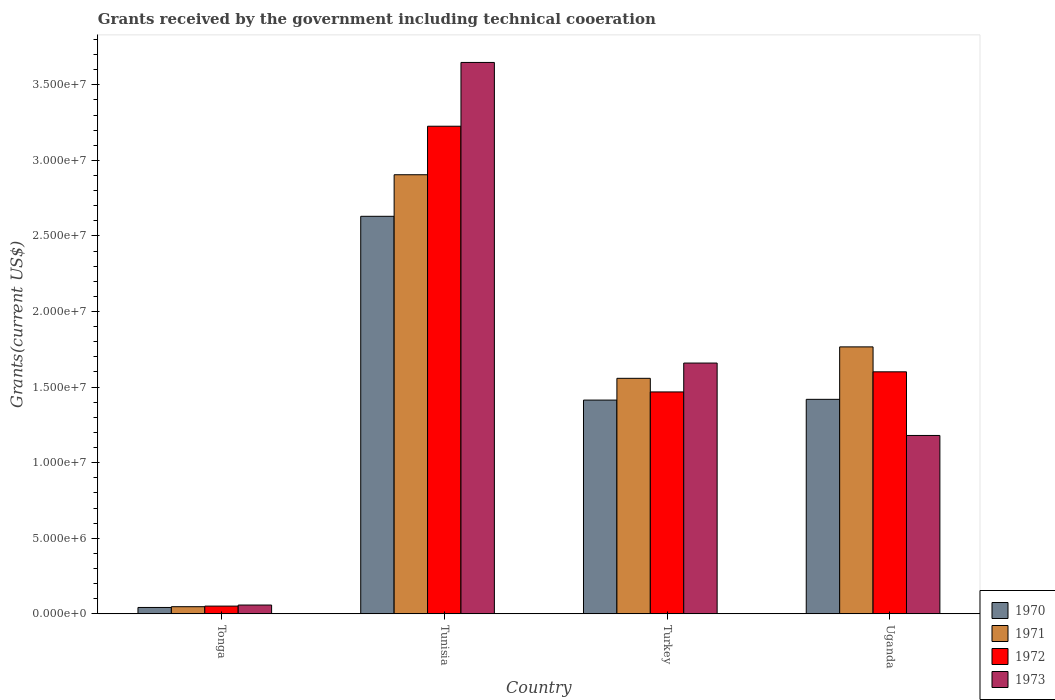How many groups of bars are there?
Offer a very short reply. 4. Are the number of bars on each tick of the X-axis equal?
Your answer should be compact. Yes. How many bars are there on the 2nd tick from the left?
Offer a very short reply. 4. What is the label of the 2nd group of bars from the left?
Offer a very short reply. Tunisia. In how many cases, is the number of bars for a given country not equal to the number of legend labels?
Your response must be concise. 0. What is the total grants received by the government in 1973 in Uganda?
Your answer should be compact. 1.18e+07. Across all countries, what is the maximum total grants received by the government in 1973?
Make the answer very short. 3.65e+07. Across all countries, what is the minimum total grants received by the government in 1971?
Provide a succinct answer. 4.70e+05. In which country was the total grants received by the government in 1972 maximum?
Give a very brief answer. Tunisia. In which country was the total grants received by the government in 1970 minimum?
Your response must be concise. Tonga. What is the total total grants received by the government in 1970 in the graph?
Make the answer very short. 5.50e+07. What is the difference between the total grants received by the government in 1973 in Tonga and that in Tunisia?
Your answer should be compact. -3.59e+07. What is the difference between the total grants received by the government in 1972 in Turkey and the total grants received by the government in 1973 in Uganda?
Ensure brevity in your answer.  2.88e+06. What is the average total grants received by the government in 1970 per country?
Ensure brevity in your answer.  1.38e+07. What is the difference between the total grants received by the government of/in 1971 and total grants received by the government of/in 1970 in Turkey?
Your answer should be compact. 1.44e+06. In how many countries, is the total grants received by the government in 1972 greater than 32000000 US$?
Offer a terse response. 1. What is the ratio of the total grants received by the government in 1970 in Tonga to that in Uganda?
Your answer should be compact. 0.03. Is the difference between the total grants received by the government in 1971 in Tunisia and Turkey greater than the difference between the total grants received by the government in 1970 in Tunisia and Turkey?
Your response must be concise. Yes. What is the difference between the highest and the second highest total grants received by the government in 1973?
Provide a succinct answer. 1.99e+07. What is the difference between the highest and the lowest total grants received by the government in 1973?
Provide a short and direct response. 3.59e+07. In how many countries, is the total grants received by the government in 1970 greater than the average total grants received by the government in 1970 taken over all countries?
Keep it short and to the point. 3. Is the sum of the total grants received by the government in 1970 in Tonga and Tunisia greater than the maximum total grants received by the government in 1973 across all countries?
Offer a terse response. No. Is it the case that in every country, the sum of the total grants received by the government in 1973 and total grants received by the government in 1972 is greater than the sum of total grants received by the government in 1970 and total grants received by the government in 1971?
Provide a succinct answer. No. What does the 2nd bar from the left in Tonga represents?
Your answer should be very brief. 1971. Is it the case that in every country, the sum of the total grants received by the government in 1970 and total grants received by the government in 1973 is greater than the total grants received by the government in 1971?
Keep it short and to the point. Yes. How many bars are there?
Keep it short and to the point. 16. How many countries are there in the graph?
Your answer should be very brief. 4. What is the difference between two consecutive major ticks on the Y-axis?
Offer a terse response. 5.00e+06. Does the graph contain any zero values?
Your answer should be compact. No. Does the graph contain grids?
Keep it short and to the point. No. Where does the legend appear in the graph?
Make the answer very short. Bottom right. How many legend labels are there?
Provide a succinct answer. 4. What is the title of the graph?
Give a very brief answer. Grants received by the government including technical cooeration. What is the label or title of the X-axis?
Your answer should be very brief. Country. What is the label or title of the Y-axis?
Provide a succinct answer. Grants(current US$). What is the Grants(current US$) in 1972 in Tonga?
Your answer should be compact. 5.10e+05. What is the Grants(current US$) in 1973 in Tonga?
Make the answer very short. 5.80e+05. What is the Grants(current US$) in 1970 in Tunisia?
Offer a very short reply. 2.63e+07. What is the Grants(current US$) in 1971 in Tunisia?
Your answer should be compact. 2.90e+07. What is the Grants(current US$) of 1972 in Tunisia?
Your response must be concise. 3.23e+07. What is the Grants(current US$) in 1973 in Tunisia?
Offer a very short reply. 3.65e+07. What is the Grants(current US$) in 1970 in Turkey?
Keep it short and to the point. 1.41e+07. What is the Grants(current US$) in 1971 in Turkey?
Your response must be concise. 1.56e+07. What is the Grants(current US$) in 1972 in Turkey?
Provide a short and direct response. 1.47e+07. What is the Grants(current US$) of 1973 in Turkey?
Keep it short and to the point. 1.66e+07. What is the Grants(current US$) of 1970 in Uganda?
Your response must be concise. 1.42e+07. What is the Grants(current US$) in 1971 in Uganda?
Ensure brevity in your answer.  1.77e+07. What is the Grants(current US$) in 1972 in Uganda?
Make the answer very short. 1.60e+07. What is the Grants(current US$) in 1973 in Uganda?
Ensure brevity in your answer.  1.18e+07. Across all countries, what is the maximum Grants(current US$) of 1970?
Your answer should be compact. 2.63e+07. Across all countries, what is the maximum Grants(current US$) of 1971?
Your answer should be compact. 2.90e+07. Across all countries, what is the maximum Grants(current US$) in 1972?
Give a very brief answer. 3.23e+07. Across all countries, what is the maximum Grants(current US$) in 1973?
Give a very brief answer. 3.65e+07. Across all countries, what is the minimum Grants(current US$) of 1972?
Your response must be concise. 5.10e+05. Across all countries, what is the minimum Grants(current US$) in 1973?
Your answer should be compact. 5.80e+05. What is the total Grants(current US$) in 1970 in the graph?
Offer a very short reply. 5.50e+07. What is the total Grants(current US$) in 1971 in the graph?
Ensure brevity in your answer.  6.28e+07. What is the total Grants(current US$) of 1972 in the graph?
Provide a succinct answer. 6.35e+07. What is the total Grants(current US$) in 1973 in the graph?
Ensure brevity in your answer.  6.54e+07. What is the difference between the Grants(current US$) in 1970 in Tonga and that in Tunisia?
Give a very brief answer. -2.59e+07. What is the difference between the Grants(current US$) in 1971 in Tonga and that in Tunisia?
Give a very brief answer. -2.86e+07. What is the difference between the Grants(current US$) of 1972 in Tonga and that in Tunisia?
Ensure brevity in your answer.  -3.18e+07. What is the difference between the Grants(current US$) in 1973 in Tonga and that in Tunisia?
Your answer should be very brief. -3.59e+07. What is the difference between the Grants(current US$) of 1970 in Tonga and that in Turkey?
Keep it short and to the point. -1.37e+07. What is the difference between the Grants(current US$) in 1971 in Tonga and that in Turkey?
Provide a succinct answer. -1.51e+07. What is the difference between the Grants(current US$) in 1972 in Tonga and that in Turkey?
Your response must be concise. -1.42e+07. What is the difference between the Grants(current US$) in 1973 in Tonga and that in Turkey?
Give a very brief answer. -1.60e+07. What is the difference between the Grants(current US$) of 1970 in Tonga and that in Uganda?
Your response must be concise. -1.38e+07. What is the difference between the Grants(current US$) of 1971 in Tonga and that in Uganda?
Provide a short and direct response. -1.72e+07. What is the difference between the Grants(current US$) of 1972 in Tonga and that in Uganda?
Provide a succinct answer. -1.55e+07. What is the difference between the Grants(current US$) in 1973 in Tonga and that in Uganda?
Your response must be concise. -1.12e+07. What is the difference between the Grants(current US$) of 1970 in Tunisia and that in Turkey?
Make the answer very short. 1.22e+07. What is the difference between the Grants(current US$) of 1971 in Tunisia and that in Turkey?
Give a very brief answer. 1.35e+07. What is the difference between the Grants(current US$) of 1972 in Tunisia and that in Turkey?
Provide a short and direct response. 1.76e+07. What is the difference between the Grants(current US$) in 1973 in Tunisia and that in Turkey?
Ensure brevity in your answer.  1.99e+07. What is the difference between the Grants(current US$) of 1970 in Tunisia and that in Uganda?
Ensure brevity in your answer.  1.21e+07. What is the difference between the Grants(current US$) of 1971 in Tunisia and that in Uganda?
Provide a short and direct response. 1.14e+07. What is the difference between the Grants(current US$) in 1972 in Tunisia and that in Uganda?
Give a very brief answer. 1.62e+07. What is the difference between the Grants(current US$) of 1973 in Tunisia and that in Uganda?
Ensure brevity in your answer.  2.47e+07. What is the difference between the Grants(current US$) of 1970 in Turkey and that in Uganda?
Ensure brevity in your answer.  -5.00e+04. What is the difference between the Grants(current US$) in 1971 in Turkey and that in Uganda?
Provide a short and direct response. -2.08e+06. What is the difference between the Grants(current US$) in 1972 in Turkey and that in Uganda?
Your answer should be very brief. -1.33e+06. What is the difference between the Grants(current US$) in 1973 in Turkey and that in Uganda?
Ensure brevity in your answer.  4.79e+06. What is the difference between the Grants(current US$) of 1970 in Tonga and the Grants(current US$) of 1971 in Tunisia?
Your answer should be very brief. -2.86e+07. What is the difference between the Grants(current US$) in 1970 in Tonga and the Grants(current US$) in 1972 in Tunisia?
Offer a very short reply. -3.18e+07. What is the difference between the Grants(current US$) in 1970 in Tonga and the Grants(current US$) in 1973 in Tunisia?
Your response must be concise. -3.61e+07. What is the difference between the Grants(current US$) of 1971 in Tonga and the Grants(current US$) of 1972 in Tunisia?
Your answer should be very brief. -3.18e+07. What is the difference between the Grants(current US$) in 1971 in Tonga and the Grants(current US$) in 1973 in Tunisia?
Give a very brief answer. -3.60e+07. What is the difference between the Grants(current US$) in 1972 in Tonga and the Grants(current US$) in 1973 in Tunisia?
Offer a very short reply. -3.60e+07. What is the difference between the Grants(current US$) in 1970 in Tonga and the Grants(current US$) in 1971 in Turkey?
Your response must be concise. -1.52e+07. What is the difference between the Grants(current US$) in 1970 in Tonga and the Grants(current US$) in 1972 in Turkey?
Your answer should be very brief. -1.43e+07. What is the difference between the Grants(current US$) in 1970 in Tonga and the Grants(current US$) in 1973 in Turkey?
Offer a very short reply. -1.62e+07. What is the difference between the Grants(current US$) in 1971 in Tonga and the Grants(current US$) in 1972 in Turkey?
Your answer should be very brief. -1.42e+07. What is the difference between the Grants(current US$) of 1971 in Tonga and the Grants(current US$) of 1973 in Turkey?
Ensure brevity in your answer.  -1.61e+07. What is the difference between the Grants(current US$) in 1972 in Tonga and the Grants(current US$) in 1973 in Turkey?
Your response must be concise. -1.61e+07. What is the difference between the Grants(current US$) in 1970 in Tonga and the Grants(current US$) in 1971 in Uganda?
Your response must be concise. -1.72e+07. What is the difference between the Grants(current US$) of 1970 in Tonga and the Grants(current US$) of 1972 in Uganda?
Provide a short and direct response. -1.56e+07. What is the difference between the Grants(current US$) in 1970 in Tonga and the Grants(current US$) in 1973 in Uganda?
Your answer should be compact. -1.14e+07. What is the difference between the Grants(current US$) in 1971 in Tonga and the Grants(current US$) in 1972 in Uganda?
Make the answer very short. -1.55e+07. What is the difference between the Grants(current US$) of 1971 in Tonga and the Grants(current US$) of 1973 in Uganda?
Provide a short and direct response. -1.13e+07. What is the difference between the Grants(current US$) in 1972 in Tonga and the Grants(current US$) in 1973 in Uganda?
Your answer should be very brief. -1.13e+07. What is the difference between the Grants(current US$) of 1970 in Tunisia and the Grants(current US$) of 1971 in Turkey?
Make the answer very short. 1.07e+07. What is the difference between the Grants(current US$) in 1970 in Tunisia and the Grants(current US$) in 1972 in Turkey?
Keep it short and to the point. 1.16e+07. What is the difference between the Grants(current US$) of 1970 in Tunisia and the Grants(current US$) of 1973 in Turkey?
Your answer should be very brief. 9.71e+06. What is the difference between the Grants(current US$) in 1971 in Tunisia and the Grants(current US$) in 1972 in Turkey?
Your answer should be compact. 1.44e+07. What is the difference between the Grants(current US$) of 1971 in Tunisia and the Grants(current US$) of 1973 in Turkey?
Your answer should be very brief. 1.25e+07. What is the difference between the Grants(current US$) of 1972 in Tunisia and the Grants(current US$) of 1973 in Turkey?
Your response must be concise. 1.57e+07. What is the difference between the Grants(current US$) in 1970 in Tunisia and the Grants(current US$) in 1971 in Uganda?
Offer a terse response. 8.64e+06. What is the difference between the Grants(current US$) in 1970 in Tunisia and the Grants(current US$) in 1972 in Uganda?
Provide a succinct answer. 1.03e+07. What is the difference between the Grants(current US$) in 1970 in Tunisia and the Grants(current US$) in 1973 in Uganda?
Offer a terse response. 1.45e+07. What is the difference between the Grants(current US$) of 1971 in Tunisia and the Grants(current US$) of 1972 in Uganda?
Offer a very short reply. 1.30e+07. What is the difference between the Grants(current US$) of 1971 in Tunisia and the Grants(current US$) of 1973 in Uganda?
Offer a very short reply. 1.72e+07. What is the difference between the Grants(current US$) of 1972 in Tunisia and the Grants(current US$) of 1973 in Uganda?
Offer a terse response. 2.05e+07. What is the difference between the Grants(current US$) of 1970 in Turkey and the Grants(current US$) of 1971 in Uganda?
Provide a short and direct response. -3.52e+06. What is the difference between the Grants(current US$) in 1970 in Turkey and the Grants(current US$) in 1972 in Uganda?
Provide a short and direct response. -1.87e+06. What is the difference between the Grants(current US$) of 1970 in Turkey and the Grants(current US$) of 1973 in Uganda?
Provide a succinct answer. 2.34e+06. What is the difference between the Grants(current US$) in 1971 in Turkey and the Grants(current US$) in 1972 in Uganda?
Your response must be concise. -4.30e+05. What is the difference between the Grants(current US$) of 1971 in Turkey and the Grants(current US$) of 1973 in Uganda?
Keep it short and to the point. 3.78e+06. What is the difference between the Grants(current US$) in 1972 in Turkey and the Grants(current US$) in 1973 in Uganda?
Give a very brief answer. 2.88e+06. What is the average Grants(current US$) of 1970 per country?
Give a very brief answer. 1.38e+07. What is the average Grants(current US$) of 1971 per country?
Your answer should be very brief. 1.57e+07. What is the average Grants(current US$) of 1972 per country?
Keep it short and to the point. 1.59e+07. What is the average Grants(current US$) of 1973 per country?
Ensure brevity in your answer.  1.64e+07. What is the difference between the Grants(current US$) in 1970 and Grants(current US$) in 1971 in Tonga?
Give a very brief answer. -5.00e+04. What is the difference between the Grants(current US$) in 1970 and Grants(current US$) in 1972 in Tonga?
Your answer should be compact. -9.00e+04. What is the difference between the Grants(current US$) of 1970 and Grants(current US$) of 1973 in Tonga?
Provide a short and direct response. -1.60e+05. What is the difference between the Grants(current US$) of 1971 and Grants(current US$) of 1972 in Tonga?
Make the answer very short. -4.00e+04. What is the difference between the Grants(current US$) of 1971 and Grants(current US$) of 1973 in Tonga?
Provide a succinct answer. -1.10e+05. What is the difference between the Grants(current US$) in 1970 and Grants(current US$) in 1971 in Tunisia?
Your answer should be compact. -2.75e+06. What is the difference between the Grants(current US$) in 1970 and Grants(current US$) in 1972 in Tunisia?
Offer a terse response. -5.96e+06. What is the difference between the Grants(current US$) in 1970 and Grants(current US$) in 1973 in Tunisia?
Offer a terse response. -1.02e+07. What is the difference between the Grants(current US$) in 1971 and Grants(current US$) in 1972 in Tunisia?
Your answer should be very brief. -3.21e+06. What is the difference between the Grants(current US$) in 1971 and Grants(current US$) in 1973 in Tunisia?
Offer a very short reply. -7.43e+06. What is the difference between the Grants(current US$) in 1972 and Grants(current US$) in 1973 in Tunisia?
Offer a very short reply. -4.22e+06. What is the difference between the Grants(current US$) of 1970 and Grants(current US$) of 1971 in Turkey?
Provide a short and direct response. -1.44e+06. What is the difference between the Grants(current US$) of 1970 and Grants(current US$) of 1972 in Turkey?
Ensure brevity in your answer.  -5.40e+05. What is the difference between the Grants(current US$) in 1970 and Grants(current US$) in 1973 in Turkey?
Keep it short and to the point. -2.45e+06. What is the difference between the Grants(current US$) in 1971 and Grants(current US$) in 1972 in Turkey?
Keep it short and to the point. 9.00e+05. What is the difference between the Grants(current US$) of 1971 and Grants(current US$) of 1973 in Turkey?
Your answer should be very brief. -1.01e+06. What is the difference between the Grants(current US$) of 1972 and Grants(current US$) of 1973 in Turkey?
Provide a short and direct response. -1.91e+06. What is the difference between the Grants(current US$) in 1970 and Grants(current US$) in 1971 in Uganda?
Keep it short and to the point. -3.47e+06. What is the difference between the Grants(current US$) in 1970 and Grants(current US$) in 1972 in Uganda?
Offer a terse response. -1.82e+06. What is the difference between the Grants(current US$) of 1970 and Grants(current US$) of 1973 in Uganda?
Your answer should be compact. 2.39e+06. What is the difference between the Grants(current US$) of 1971 and Grants(current US$) of 1972 in Uganda?
Your answer should be very brief. 1.65e+06. What is the difference between the Grants(current US$) of 1971 and Grants(current US$) of 1973 in Uganda?
Give a very brief answer. 5.86e+06. What is the difference between the Grants(current US$) of 1972 and Grants(current US$) of 1973 in Uganda?
Offer a very short reply. 4.21e+06. What is the ratio of the Grants(current US$) in 1970 in Tonga to that in Tunisia?
Offer a terse response. 0.02. What is the ratio of the Grants(current US$) of 1971 in Tonga to that in Tunisia?
Your answer should be compact. 0.02. What is the ratio of the Grants(current US$) in 1972 in Tonga to that in Tunisia?
Keep it short and to the point. 0.02. What is the ratio of the Grants(current US$) of 1973 in Tonga to that in Tunisia?
Ensure brevity in your answer.  0.02. What is the ratio of the Grants(current US$) in 1970 in Tonga to that in Turkey?
Give a very brief answer. 0.03. What is the ratio of the Grants(current US$) in 1971 in Tonga to that in Turkey?
Offer a terse response. 0.03. What is the ratio of the Grants(current US$) of 1972 in Tonga to that in Turkey?
Provide a succinct answer. 0.03. What is the ratio of the Grants(current US$) in 1973 in Tonga to that in Turkey?
Give a very brief answer. 0.04. What is the ratio of the Grants(current US$) of 1970 in Tonga to that in Uganda?
Provide a short and direct response. 0.03. What is the ratio of the Grants(current US$) in 1971 in Tonga to that in Uganda?
Ensure brevity in your answer.  0.03. What is the ratio of the Grants(current US$) of 1972 in Tonga to that in Uganda?
Your answer should be compact. 0.03. What is the ratio of the Grants(current US$) in 1973 in Tonga to that in Uganda?
Your answer should be compact. 0.05. What is the ratio of the Grants(current US$) in 1970 in Tunisia to that in Turkey?
Your response must be concise. 1.86. What is the ratio of the Grants(current US$) in 1971 in Tunisia to that in Turkey?
Make the answer very short. 1.86. What is the ratio of the Grants(current US$) in 1972 in Tunisia to that in Turkey?
Make the answer very short. 2.2. What is the ratio of the Grants(current US$) of 1973 in Tunisia to that in Turkey?
Keep it short and to the point. 2.2. What is the ratio of the Grants(current US$) of 1970 in Tunisia to that in Uganda?
Ensure brevity in your answer.  1.85. What is the ratio of the Grants(current US$) of 1971 in Tunisia to that in Uganda?
Keep it short and to the point. 1.65. What is the ratio of the Grants(current US$) of 1972 in Tunisia to that in Uganda?
Provide a short and direct response. 2.02. What is the ratio of the Grants(current US$) of 1973 in Tunisia to that in Uganda?
Give a very brief answer. 3.09. What is the ratio of the Grants(current US$) of 1970 in Turkey to that in Uganda?
Make the answer very short. 1. What is the ratio of the Grants(current US$) of 1971 in Turkey to that in Uganda?
Give a very brief answer. 0.88. What is the ratio of the Grants(current US$) in 1972 in Turkey to that in Uganda?
Make the answer very short. 0.92. What is the ratio of the Grants(current US$) in 1973 in Turkey to that in Uganda?
Ensure brevity in your answer.  1.41. What is the difference between the highest and the second highest Grants(current US$) in 1970?
Provide a short and direct response. 1.21e+07. What is the difference between the highest and the second highest Grants(current US$) of 1971?
Provide a short and direct response. 1.14e+07. What is the difference between the highest and the second highest Grants(current US$) in 1972?
Make the answer very short. 1.62e+07. What is the difference between the highest and the second highest Grants(current US$) of 1973?
Keep it short and to the point. 1.99e+07. What is the difference between the highest and the lowest Grants(current US$) in 1970?
Ensure brevity in your answer.  2.59e+07. What is the difference between the highest and the lowest Grants(current US$) of 1971?
Your response must be concise. 2.86e+07. What is the difference between the highest and the lowest Grants(current US$) in 1972?
Offer a terse response. 3.18e+07. What is the difference between the highest and the lowest Grants(current US$) in 1973?
Your response must be concise. 3.59e+07. 